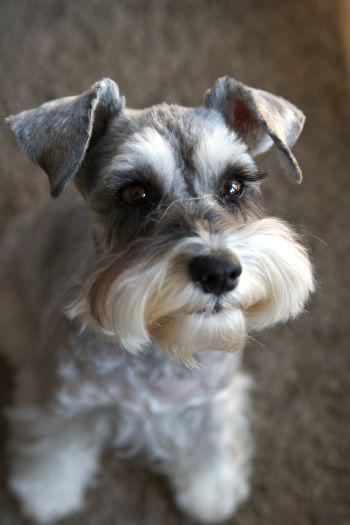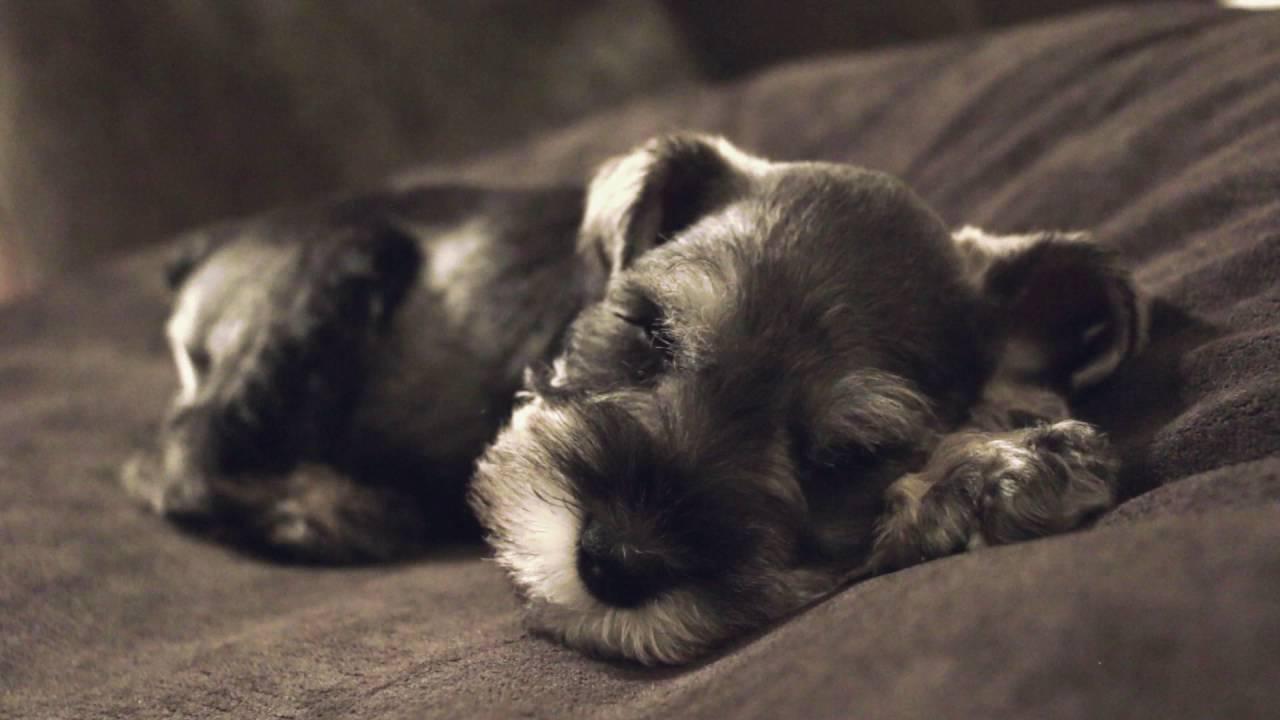The first image is the image on the left, the second image is the image on the right. Evaluate the accuracy of this statement regarding the images: "Each image contains one schnauzer posed on a piece of soft furniture.". Is it true? Answer yes or no. No. The first image is the image on the left, the second image is the image on the right. Assess this claim about the two images: "A dog is lying down on a white bed sheet in the left image.". Correct or not? Answer yes or no. No. 